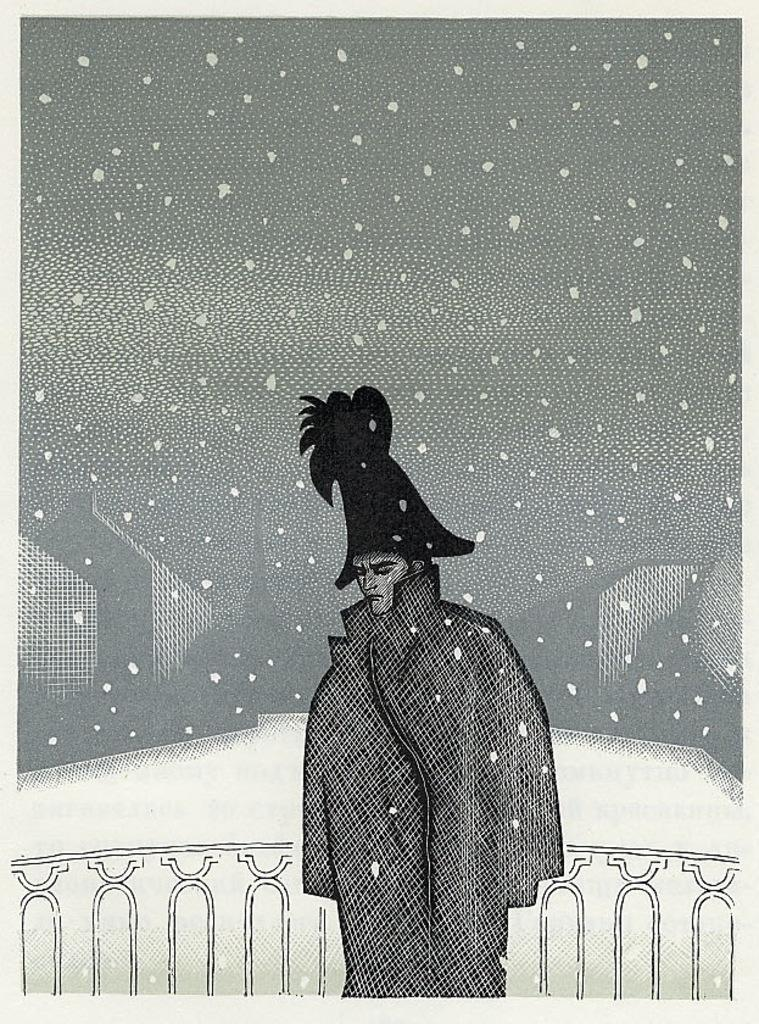What type of character is present in the image? There is a cartoon character in the image. What is the cartoon character wearing? The cartoon character is wearing clothes and a hat. What type of cable is connected to the cartoon character's hat in the image? There is no cable connected to the cartoon character's hat in the image. 